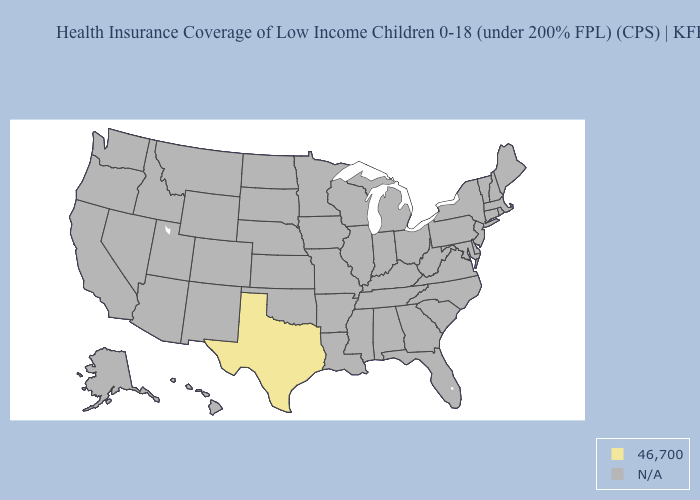What is the lowest value in the South?
Quick response, please. 46,700. What is the value of West Virginia?
Keep it brief. N/A. What is the value of Hawaii?
Quick response, please. N/A. What is the value of New Hampshire?
Short answer required. N/A. What is the value of Kansas?
Answer briefly. N/A. Name the states that have a value in the range 46,700?
Keep it brief. Texas. What is the value of Kansas?
Concise answer only. N/A. Name the states that have a value in the range 46,700?
Quick response, please. Texas. What is the value of Ohio?
Be succinct. N/A. 